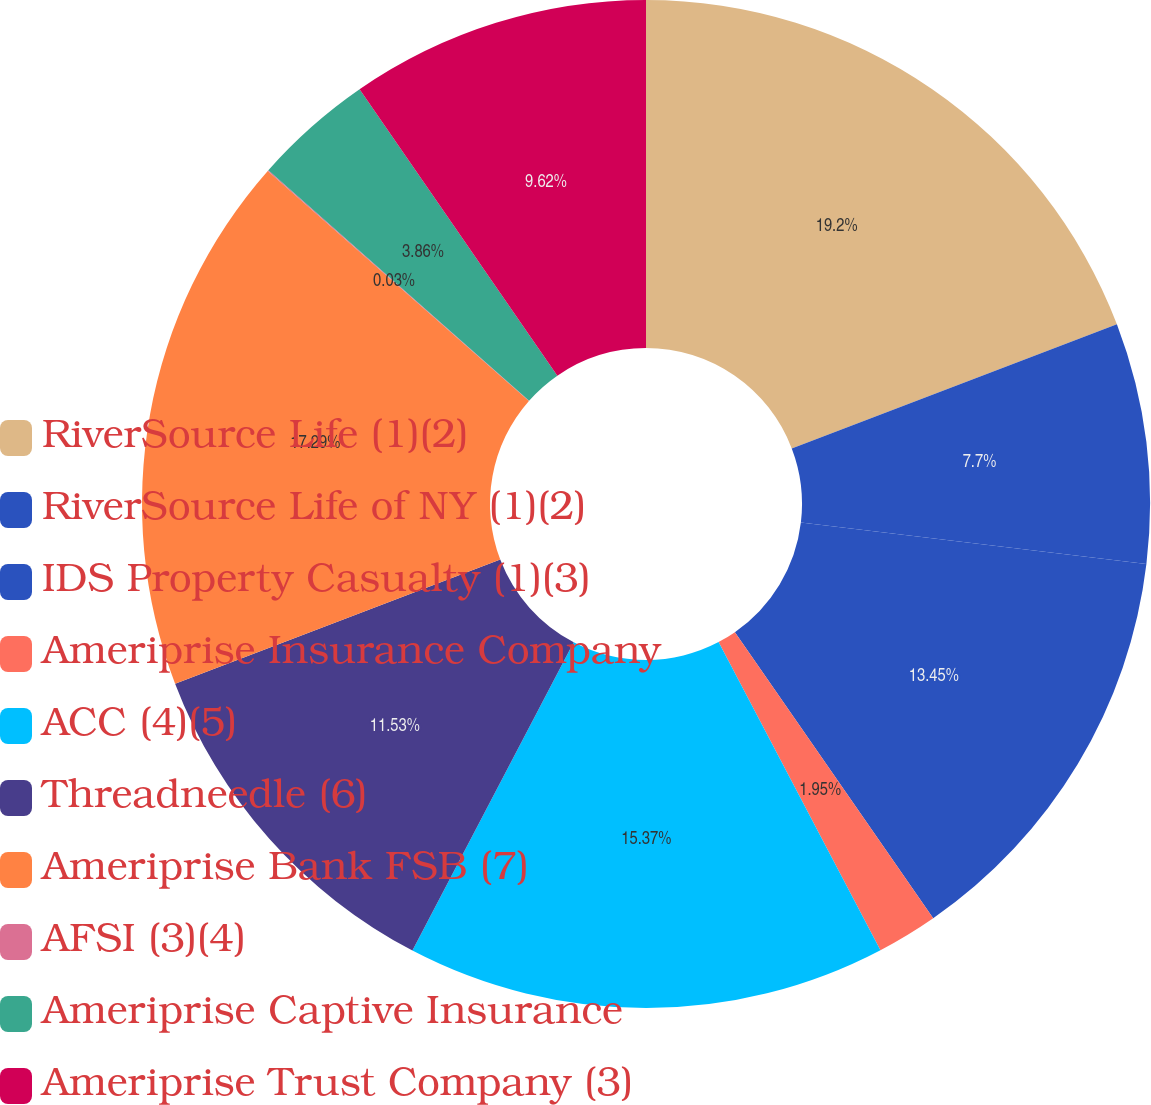Convert chart to OTSL. <chart><loc_0><loc_0><loc_500><loc_500><pie_chart><fcel>RiverSource Life (1)(2)<fcel>RiverSource Life of NY (1)(2)<fcel>IDS Property Casualty (1)(3)<fcel>Ameriprise Insurance Company<fcel>ACC (4)(5)<fcel>Threadneedle (6)<fcel>Ameriprise Bank FSB (7)<fcel>AFSI (3)(4)<fcel>Ameriprise Captive Insurance<fcel>Ameriprise Trust Company (3)<nl><fcel>19.2%<fcel>7.7%<fcel>13.45%<fcel>1.95%<fcel>15.37%<fcel>11.53%<fcel>17.29%<fcel>0.03%<fcel>3.86%<fcel>9.62%<nl></chart> 